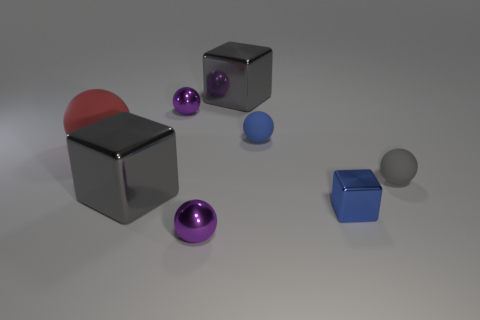Subtract all gray balls. How many balls are left? 4 Subtract all large blocks. How many blocks are left? 1 Subtract all blocks. How many objects are left? 5 Subtract all purple spheres. How many red blocks are left? 0 Subtract all big things. Subtract all blue metallic cubes. How many objects are left? 4 Add 6 blocks. How many blocks are left? 9 Add 3 blue spheres. How many blue spheres exist? 4 Add 1 tiny purple shiny things. How many objects exist? 9 Subtract 0 brown blocks. How many objects are left? 8 Subtract 1 balls. How many balls are left? 4 